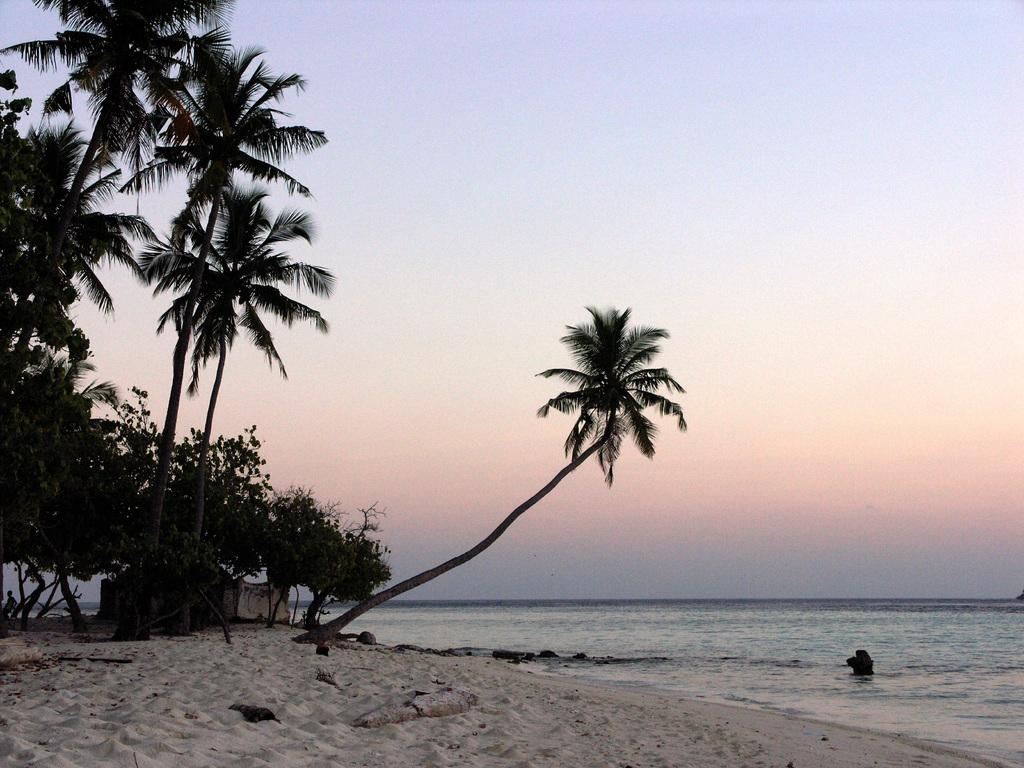What type of vegetation is present in the image? There are trees in the image. What type of structure can be seen in the image? There is a wall in the image. What type of terrain is visible in the image? There is sand in the image. What natural element is present in the image? There is water in the image. What type of material is present in the image? There are stones in the image. What else can be seen in the image? There are some objects in the image. What is visible in the background of the image? The sky is visible in the background of the image. Can you tell me how many beggars are present in the image? There are no beggars present in the image. What type of straw is used to build the wall in the image? There is no straw used to build the wall in the image; it is not mentioned in the provided facts. 